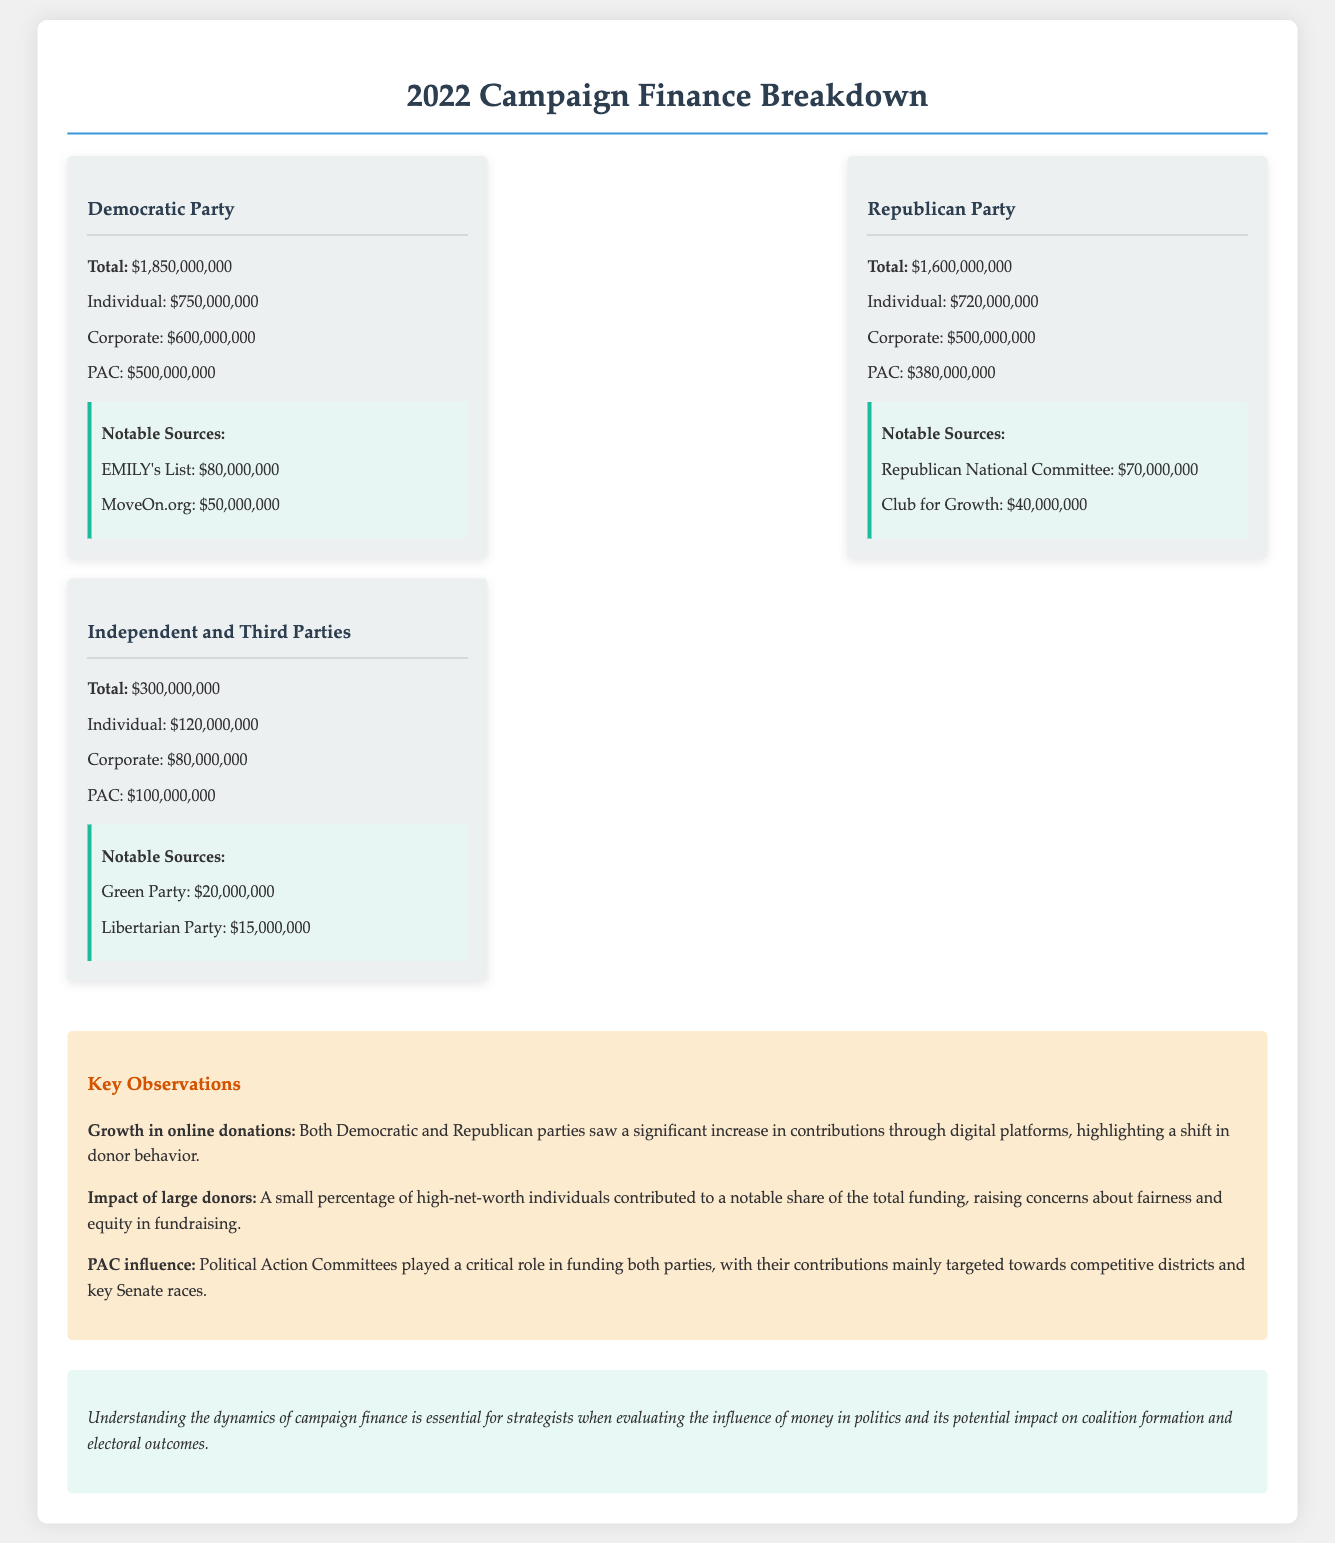What is the total contribution of the Democratic Party? The total contribution for the Democratic Party is provided in the document as $1,850,000,000.
Answer: $1,850,000,000 What is the total contribution of the Republican Party? The total contribution for the Republican Party is specified as $1,600,000,000.
Answer: $1,600,000,000 Which organization contributed $80,000,000 to the Democratic Party? The document states that EMILY's List contributed $80,000,000 to the Democratic Party.
Answer: EMILY's List What percentage of the Independent and Third Parties' total contributions came from individuals? The document indicates that individuals contributed $120,000,000 out of a total of $300,000,000 for the Independent and Third Parties, which is 40%.
Answer: 40% What key observation highlights the role of PACs? The document notes that PACs played a critical role in funding both parties, highlighting their contributions to competitive districts.
Answer: PAC influence What was a notable source of funding for the Republican Party? The document mentions the Republican National Committee as a notable source with $70,000,000.
Answer: Republican National Committee How much did MoveOn.org contribute to the Democratic Party? According to the document, MoveOn.org contributed $50,000,000.
Answer: $50,000,000 What is the total contribution from Corporate sources to the Republican Party? The document indicates that Corporate contributions to the Republican Party totaled $500,000,000.
Answer: $500,000,000 What is emphasized about the growth in online donations? The key observation states that both parties saw a significant increase in contributions through digital platforms.
Answer: Growth in online donations 